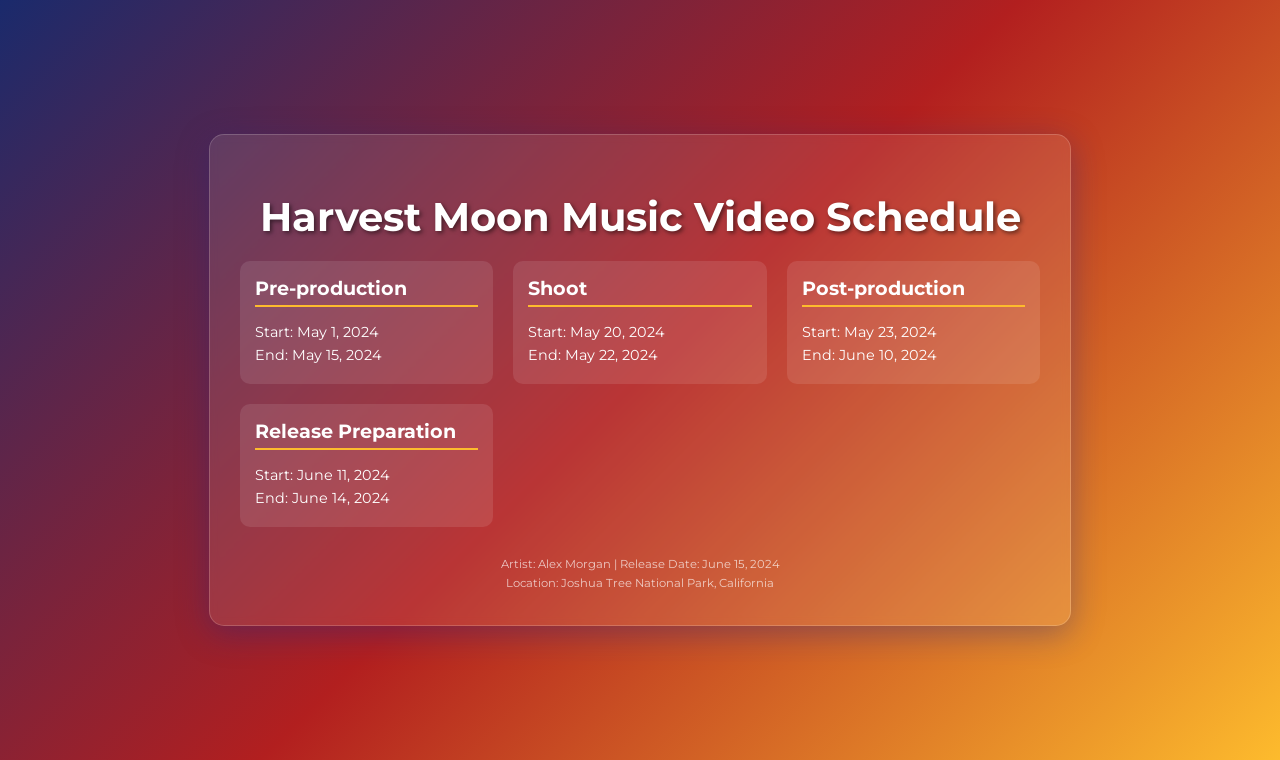What is the start date of pre-production? The start date is specifically mentioned in the schedule section for pre-production.
Answer: May 1, 2024 What is the end date of the shoot? The end date is provided under the shoot phase in the document.
Answer: May 22, 2024 What is the location of the music video shoot? The location is clearly stated in the footer of the document.
Answer: Joshua Tree National Park, California How many days is the post-production scheduled to last? The number of days can be calculated by finding the difference between the start and end dates provided for post-production.
Answer: 18 days What is the release date of the music video? The release date is specified in the footer section of the document.
Answer: June 15, 2024 What phase starts immediately after the shoot phase? Understanding the flow of the phases allows us to determine this based on the order they are listed.
Answer: Post-production What is the duration of the release preparation phase? The duration can be found by calculating the difference between the start and end dates for the release preparation phase.
Answer: 4 days In which month does the pre-production start? The month is included in the start date of the pre-production phase.
Answer: May What is the title of the music video? The title is implicit in the document's heading.
Answer: Harvest Moon 